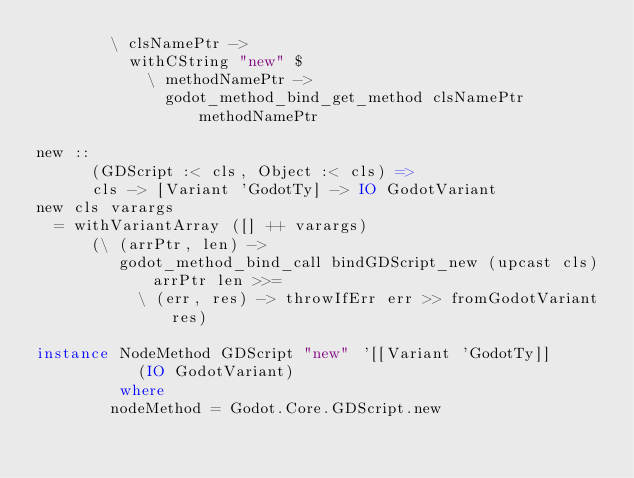<code> <loc_0><loc_0><loc_500><loc_500><_Haskell_>        \ clsNamePtr ->
          withCString "new" $
            \ methodNamePtr ->
              godot_method_bind_get_method clsNamePtr methodNamePtr

new ::
      (GDScript :< cls, Object :< cls) =>
      cls -> [Variant 'GodotTy] -> IO GodotVariant
new cls varargs
  = withVariantArray ([] ++ varargs)
      (\ (arrPtr, len) ->
         godot_method_bind_call bindGDScript_new (upcast cls) arrPtr len >>=
           \ (err, res) -> throwIfErr err >> fromGodotVariant res)

instance NodeMethod GDScript "new" '[[Variant 'GodotTy]]
           (IO GodotVariant)
         where
        nodeMethod = Godot.Core.GDScript.new</code> 